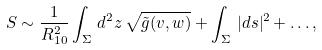<formula> <loc_0><loc_0><loc_500><loc_500>S \sim \frac { 1 } { R _ { 1 0 } ^ { 2 } } \int _ { \Sigma } \, d ^ { 2 } z \, \sqrt { \tilde { g } ( v , w ) } + \int _ { \Sigma } \, | d s | ^ { 2 } + \dots ,</formula> 